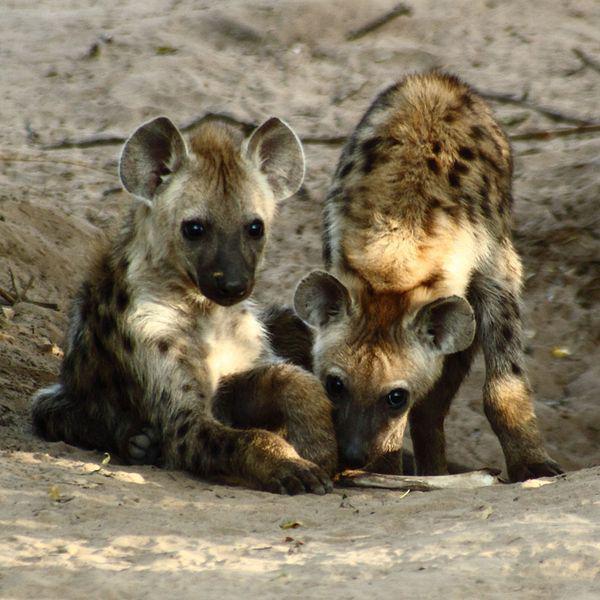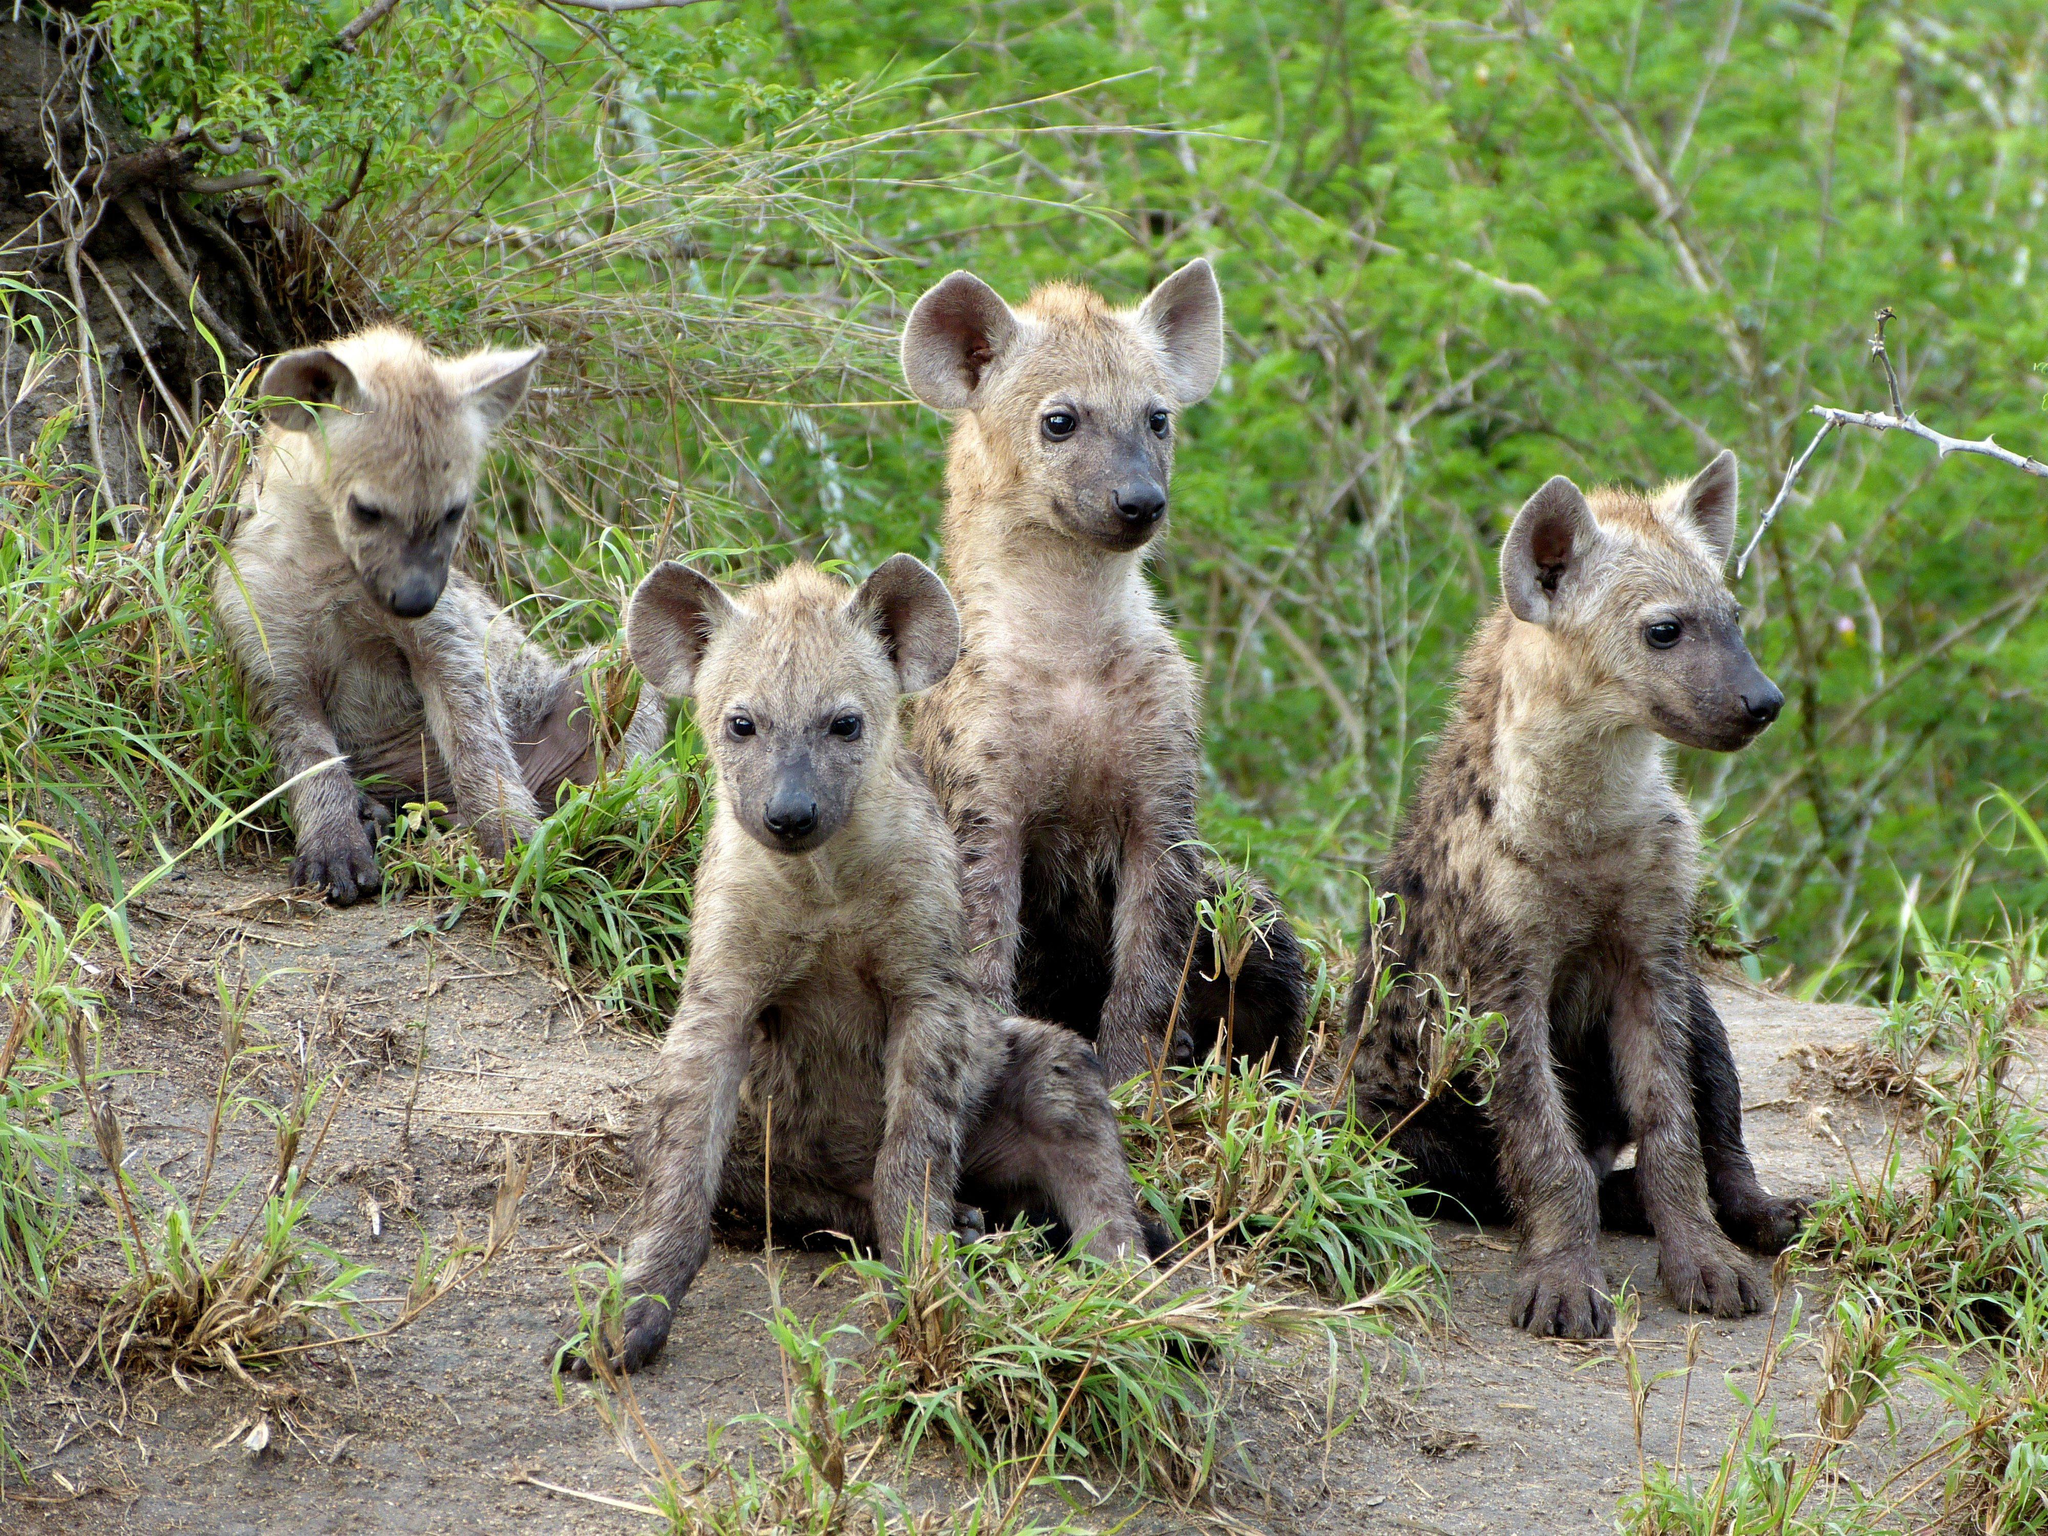The first image is the image on the left, the second image is the image on the right. Examine the images to the left and right. Is the description "The right image contains exactly two hyenas." accurate? Answer yes or no. No. The first image is the image on the left, the second image is the image on the right. Analyze the images presented: Is the assertion "One image includes a dark hyena pup and an adult hyena, and shows their heads one above the other." valid? Answer yes or no. No. 